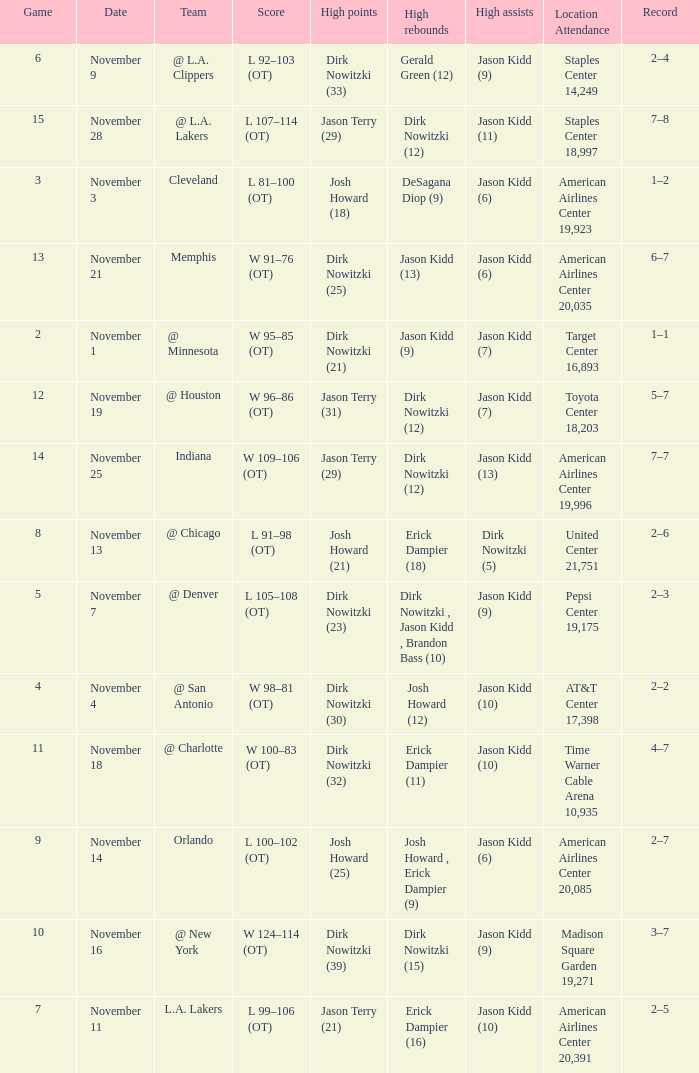What was the record on November 7? 1.0. 